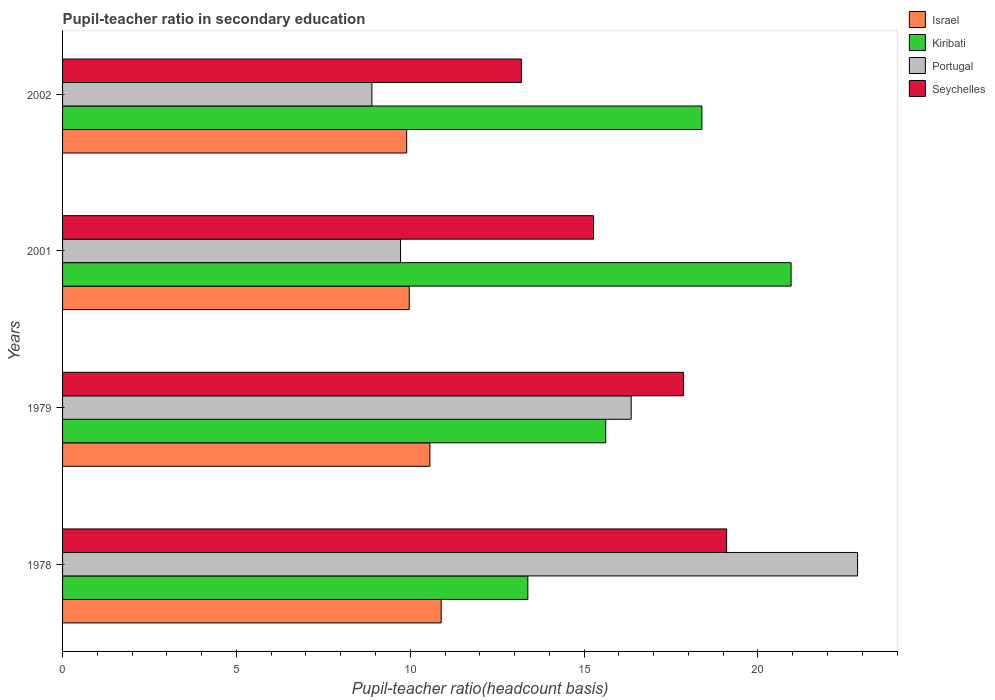How many groups of bars are there?
Make the answer very short. 4. Are the number of bars per tick equal to the number of legend labels?
Your answer should be very brief. Yes. Are the number of bars on each tick of the Y-axis equal?
Make the answer very short. Yes. How many bars are there on the 4th tick from the top?
Offer a terse response. 4. How many bars are there on the 2nd tick from the bottom?
Keep it short and to the point. 4. What is the label of the 4th group of bars from the top?
Your response must be concise. 1978. What is the pupil-teacher ratio in secondary education in Portugal in 2001?
Your response must be concise. 9.72. Across all years, what is the maximum pupil-teacher ratio in secondary education in Seychelles?
Offer a terse response. 19.1. Across all years, what is the minimum pupil-teacher ratio in secondary education in Portugal?
Offer a very short reply. 8.9. In which year was the pupil-teacher ratio in secondary education in Kiribati maximum?
Make the answer very short. 2001. In which year was the pupil-teacher ratio in secondary education in Portugal minimum?
Provide a succinct answer. 2002. What is the total pupil-teacher ratio in secondary education in Israel in the graph?
Give a very brief answer. 41.32. What is the difference between the pupil-teacher ratio in secondary education in Portugal in 1979 and that in 2001?
Your response must be concise. 6.63. What is the difference between the pupil-teacher ratio in secondary education in Portugal in 1978 and the pupil-teacher ratio in secondary education in Seychelles in 2001?
Ensure brevity in your answer.  7.6. What is the average pupil-teacher ratio in secondary education in Seychelles per year?
Provide a succinct answer. 16.36. In the year 2002, what is the difference between the pupil-teacher ratio in secondary education in Portugal and pupil-teacher ratio in secondary education in Israel?
Provide a succinct answer. -1. In how many years, is the pupil-teacher ratio in secondary education in Seychelles greater than 12 ?
Make the answer very short. 4. What is the ratio of the pupil-teacher ratio in secondary education in Israel in 1978 to that in 1979?
Offer a terse response. 1.03. Is the pupil-teacher ratio in secondary education in Kiribati in 1979 less than that in 2001?
Your response must be concise. Yes. Is the difference between the pupil-teacher ratio in secondary education in Portugal in 1978 and 2001 greater than the difference between the pupil-teacher ratio in secondary education in Israel in 1978 and 2001?
Ensure brevity in your answer.  Yes. What is the difference between the highest and the second highest pupil-teacher ratio in secondary education in Seychelles?
Your response must be concise. 1.24. What is the difference between the highest and the lowest pupil-teacher ratio in secondary education in Seychelles?
Provide a succinct answer. 5.9. Is it the case that in every year, the sum of the pupil-teacher ratio in secondary education in Portugal and pupil-teacher ratio in secondary education in Israel is greater than the sum of pupil-teacher ratio in secondary education in Seychelles and pupil-teacher ratio in secondary education in Kiribati?
Provide a short and direct response. No. What does the 2nd bar from the bottom in 2002 represents?
Give a very brief answer. Kiribati. Is it the case that in every year, the sum of the pupil-teacher ratio in secondary education in Portugal and pupil-teacher ratio in secondary education in Israel is greater than the pupil-teacher ratio in secondary education in Kiribati?
Keep it short and to the point. No. How many bars are there?
Your answer should be compact. 16. Are all the bars in the graph horizontal?
Your answer should be compact. Yes. How many years are there in the graph?
Keep it short and to the point. 4. What is the difference between two consecutive major ticks on the X-axis?
Provide a short and direct response. 5. Does the graph contain grids?
Ensure brevity in your answer.  No. How are the legend labels stacked?
Offer a terse response. Vertical. What is the title of the graph?
Provide a succinct answer. Pupil-teacher ratio in secondary education. What is the label or title of the X-axis?
Offer a very short reply. Pupil-teacher ratio(headcount basis). What is the Pupil-teacher ratio(headcount basis) of Israel in 1978?
Your response must be concise. 10.89. What is the Pupil-teacher ratio(headcount basis) in Kiribati in 1978?
Give a very brief answer. 13.38. What is the Pupil-teacher ratio(headcount basis) of Portugal in 1978?
Offer a terse response. 22.87. What is the Pupil-teacher ratio(headcount basis) of Seychelles in 1978?
Your answer should be very brief. 19.1. What is the Pupil-teacher ratio(headcount basis) of Israel in 1979?
Offer a terse response. 10.57. What is the Pupil-teacher ratio(headcount basis) of Kiribati in 1979?
Your answer should be very brief. 15.62. What is the Pupil-teacher ratio(headcount basis) in Portugal in 1979?
Keep it short and to the point. 16.35. What is the Pupil-teacher ratio(headcount basis) in Seychelles in 1979?
Give a very brief answer. 17.86. What is the Pupil-teacher ratio(headcount basis) in Israel in 2001?
Make the answer very short. 9.97. What is the Pupil-teacher ratio(headcount basis) of Kiribati in 2001?
Your answer should be compact. 20.95. What is the Pupil-teacher ratio(headcount basis) of Portugal in 2001?
Keep it short and to the point. 9.72. What is the Pupil-teacher ratio(headcount basis) in Seychelles in 2001?
Provide a short and direct response. 15.27. What is the Pupil-teacher ratio(headcount basis) of Israel in 2002?
Your answer should be compact. 9.9. What is the Pupil-teacher ratio(headcount basis) of Kiribati in 2002?
Keep it short and to the point. 18.39. What is the Pupil-teacher ratio(headcount basis) in Portugal in 2002?
Your answer should be very brief. 8.9. What is the Pupil-teacher ratio(headcount basis) of Seychelles in 2002?
Your answer should be very brief. 13.2. Across all years, what is the maximum Pupil-teacher ratio(headcount basis) in Israel?
Provide a short and direct response. 10.89. Across all years, what is the maximum Pupil-teacher ratio(headcount basis) of Kiribati?
Your response must be concise. 20.95. Across all years, what is the maximum Pupil-teacher ratio(headcount basis) of Portugal?
Your answer should be very brief. 22.87. Across all years, what is the maximum Pupil-teacher ratio(headcount basis) of Seychelles?
Ensure brevity in your answer.  19.1. Across all years, what is the minimum Pupil-teacher ratio(headcount basis) in Israel?
Your answer should be compact. 9.9. Across all years, what is the minimum Pupil-teacher ratio(headcount basis) in Kiribati?
Provide a short and direct response. 13.38. Across all years, what is the minimum Pupil-teacher ratio(headcount basis) of Portugal?
Provide a short and direct response. 8.9. Across all years, what is the minimum Pupil-teacher ratio(headcount basis) of Seychelles?
Provide a succinct answer. 13.2. What is the total Pupil-teacher ratio(headcount basis) in Israel in the graph?
Make the answer very short. 41.32. What is the total Pupil-teacher ratio(headcount basis) of Kiribati in the graph?
Your answer should be very brief. 68.34. What is the total Pupil-teacher ratio(headcount basis) in Portugal in the graph?
Keep it short and to the point. 57.84. What is the total Pupil-teacher ratio(headcount basis) of Seychelles in the graph?
Your response must be concise. 65.42. What is the difference between the Pupil-teacher ratio(headcount basis) of Israel in 1978 and that in 1979?
Offer a terse response. 0.32. What is the difference between the Pupil-teacher ratio(headcount basis) in Kiribati in 1978 and that in 1979?
Provide a succinct answer. -2.24. What is the difference between the Pupil-teacher ratio(headcount basis) of Portugal in 1978 and that in 1979?
Your answer should be very brief. 6.51. What is the difference between the Pupil-teacher ratio(headcount basis) in Seychelles in 1978 and that in 1979?
Make the answer very short. 1.24. What is the difference between the Pupil-teacher ratio(headcount basis) in Israel in 1978 and that in 2001?
Make the answer very short. 0.92. What is the difference between the Pupil-teacher ratio(headcount basis) of Kiribati in 1978 and that in 2001?
Your response must be concise. -7.57. What is the difference between the Pupil-teacher ratio(headcount basis) in Portugal in 1978 and that in 2001?
Offer a very short reply. 13.15. What is the difference between the Pupil-teacher ratio(headcount basis) in Seychelles in 1978 and that in 2001?
Offer a very short reply. 3.83. What is the difference between the Pupil-teacher ratio(headcount basis) of Israel in 1978 and that in 2002?
Provide a succinct answer. 0.99. What is the difference between the Pupil-teacher ratio(headcount basis) in Kiribati in 1978 and that in 2002?
Your answer should be compact. -5.01. What is the difference between the Pupil-teacher ratio(headcount basis) of Portugal in 1978 and that in 2002?
Provide a short and direct response. 13.97. What is the difference between the Pupil-teacher ratio(headcount basis) in Seychelles in 1978 and that in 2002?
Ensure brevity in your answer.  5.9. What is the difference between the Pupil-teacher ratio(headcount basis) in Israel in 1979 and that in 2001?
Make the answer very short. 0.59. What is the difference between the Pupil-teacher ratio(headcount basis) of Kiribati in 1979 and that in 2001?
Your answer should be very brief. -5.33. What is the difference between the Pupil-teacher ratio(headcount basis) of Portugal in 1979 and that in 2001?
Offer a terse response. 6.63. What is the difference between the Pupil-teacher ratio(headcount basis) in Seychelles in 1979 and that in 2001?
Ensure brevity in your answer.  2.59. What is the difference between the Pupil-teacher ratio(headcount basis) of Israel in 1979 and that in 2002?
Offer a very short reply. 0.67. What is the difference between the Pupil-teacher ratio(headcount basis) in Kiribati in 1979 and that in 2002?
Provide a succinct answer. -2.77. What is the difference between the Pupil-teacher ratio(headcount basis) of Portugal in 1979 and that in 2002?
Your answer should be compact. 7.46. What is the difference between the Pupil-teacher ratio(headcount basis) of Seychelles in 1979 and that in 2002?
Offer a terse response. 4.66. What is the difference between the Pupil-teacher ratio(headcount basis) in Israel in 2001 and that in 2002?
Keep it short and to the point. 0.07. What is the difference between the Pupil-teacher ratio(headcount basis) of Kiribati in 2001 and that in 2002?
Provide a short and direct response. 2.57. What is the difference between the Pupil-teacher ratio(headcount basis) in Portugal in 2001 and that in 2002?
Your response must be concise. 0.82. What is the difference between the Pupil-teacher ratio(headcount basis) in Seychelles in 2001 and that in 2002?
Provide a short and direct response. 2.07. What is the difference between the Pupil-teacher ratio(headcount basis) in Israel in 1978 and the Pupil-teacher ratio(headcount basis) in Kiribati in 1979?
Keep it short and to the point. -4.73. What is the difference between the Pupil-teacher ratio(headcount basis) in Israel in 1978 and the Pupil-teacher ratio(headcount basis) in Portugal in 1979?
Make the answer very short. -5.46. What is the difference between the Pupil-teacher ratio(headcount basis) in Israel in 1978 and the Pupil-teacher ratio(headcount basis) in Seychelles in 1979?
Your answer should be compact. -6.97. What is the difference between the Pupil-teacher ratio(headcount basis) in Kiribati in 1978 and the Pupil-teacher ratio(headcount basis) in Portugal in 1979?
Keep it short and to the point. -2.97. What is the difference between the Pupil-teacher ratio(headcount basis) in Kiribati in 1978 and the Pupil-teacher ratio(headcount basis) in Seychelles in 1979?
Your response must be concise. -4.48. What is the difference between the Pupil-teacher ratio(headcount basis) of Portugal in 1978 and the Pupil-teacher ratio(headcount basis) of Seychelles in 1979?
Offer a terse response. 5.01. What is the difference between the Pupil-teacher ratio(headcount basis) of Israel in 1978 and the Pupil-teacher ratio(headcount basis) of Kiribati in 2001?
Give a very brief answer. -10.06. What is the difference between the Pupil-teacher ratio(headcount basis) of Israel in 1978 and the Pupil-teacher ratio(headcount basis) of Portugal in 2001?
Provide a short and direct response. 1.17. What is the difference between the Pupil-teacher ratio(headcount basis) of Israel in 1978 and the Pupil-teacher ratio(headcount basis) of Seychelles in 2001?
Ensure brevity in your answer.  -4.38. What is the difference between the Pupil-teacher ratio(headcount basis) of Kiribati in 1978 and the Pupil-teacher ratio(headcount basis) of Portugal in 2001?
Your answer should be compact. 3.66. What is the difference between the Pupil-teacher ratio(headcount basis) of Kiribati in 1978 and the Pupil-teacher ratio(headcount basis) of Seychelles in 2001?
Provide a succinct answer. -1.89. What is the difference between the Pupil-teacher ratio(headcount basis) in Portugal in 1978 and the Pupil-teacher ratio(headcount basis) in Seychelles in 2001?
Offer a very short reply. 7.6. What is the difference between the Pupil-teacher ratio(headcount basis) in Israel in 1978 and the Pupil-teacher ratio(headcount basis) in Kiribati in 2002?
Keep it short and to the point. -7.5. What is the difference between the Pupil-teacher ratio(headcount basis) in Israel in 1978 and the Pupil-teacher ratio(headcount basis) in Portugal in 2002?
Make the answer very short. 1.99. What is the difference between the Pupil-teacher ratio(headcount basis) in Israel in 1978 and the Pupil-teacher ratio(headcount basis) in Seychelles in 2002?
Keep it short and to the point. -2.31. What is the difference between the Pupil-teacher ratio(headcount basis) in Kiribati in 1978 and the Pupil-teacher ratio(headcount basis) in Portugal in 2002?
Your response must be concise. 4.48. What is the difference between the Pupil-teacher ratio(headcount basis) in Kiribati in 1978 and the Pupil-teacher ratio(headcount basis) in Seychelles in 2002?
Make the answer very short. 0.18. What is the difference between the Pupil-teacher ratio(headcount basis) in Portugal in 1978 and the Pupil-teacher ratio(headcount basis) in Seychelles in 2002?
Give a very brief answer. 9.67. What is the difference between the Pupil-teacher ratio(headcount basis) of Israel in 1979 and the Pupil-teacher ratio(headcount basis) of Kiribati in 2001?
Make the answer very short. -10.39. What is the difference between the Pupil-teacher ratio(headcount basis) in Israel in 1979 and the Pupil-teacher ratio(headcount basis) in Portugal in 2001?
Your answer should be compact. 0.84. What is the difference between the Pupil-teacher ratio(headcount basis) in Israel in 1979 and the Pupil-teacher ratio(headcount basis) in Seychelles in 2001?
Provide a short and direct response. -4.71. What is the difference between the Pupil-teacher ratio(headcount basis) of Kiribati in 1979 and the Pupil-teacher ratio(headcount basis) of Portugal in 2001?
Your response must be concise. 5.9. What is the difference between the Pupil-teacher ratio(headcount basis) in Kiribati in 1979 and the Pupil-teacher ratio(headcount basis) in Seychelles in 2001?
Offer a terse response. 0.35. What is the difference between the Pupil-teacher ratio(headcount basis) in Portugal in 1979 and the Pupil-teacher ratio(headcount basis) in Seychelles in 2001?
Ensure brevity in your answer.  1.08. What is the difference between the Pupil-teacher ratio(headcount basis) in Israel in 1979 and the Pupil-teacher ratio(headcount basis) in Kiribati in 2002?
Provide a short and direct response. -7.82. What is the difference between the Pupil-teacher ratio(headcount basis) of Israel in 1979 and the Pupil-teacher ratio(headcount basis) of Portugal in 2002?
Your answer should be compact. 1.67. What is the difference between the Pupil-teacher ratio(headcount basis) in Israel in 1979 and the Pupil-teacher ratio(headcount basis) in Seychelles in 2002?
Your answer should be very brief. -2.63. What is the difference between the Pupil-teacher ratio(headcount basis) in Kiribati in 1979 and the Pupil-teacher ratio(headcount basis) in Portugal in 2002?
Provide a succinct answer. 6.72. What is the difference between the Pupil-teacher ratio(headcount basis) of Kiribati in 1979 and the Pupil-teacher ratio(headcount basis) of Seychelles in 2002?
Give a very brief answer. 2.42. What is the difference between the Pupil-teacher ratio(headcount basis) in Portugal in 1979 and the Pupil-teacher ratio(headcount basis) in Seychelles in 2002?
Offer a very short reply. 3.16. What is the difference between the Pupil-teacher ratio(headcount basis) of Israel in 2001 and the Pupil-teacher ratio(headcount basis) of Kiribati in 2002?
Provide a succinct answer. -8.42. What is the difference between the Pupil-teacher ratio(headcount basis) in Israel in 2001 and the Pupil-teacher ratio(headcount basis) in Portugal in 2002?
Give a very brief answer. 1.07. What is the difference between the Pupil-teacher ratio(headcount basis) of Israel in 2001 and the Pupil-teacher ratio(headcount basis) of Seychelles in 2002?
Your answer should be compact. -3.23. What is the difference between the Pupil-teacher ratio(headcount basis) of Kiribati in 2001 and the Pupil-teacher ratio(headcount basis) of Portugal in 2002?
Your answer should be very brief. 12.06. What is the difference between the Pupil-teacher ratio(headcount basis) in Kiribati in 2001 and the Pupil-teacher ratio(headcount basis) in Seychelles in 2002?
Provide a succinct answer. 7.76. What is the difference between the Pupil-teacher ratio(headcount basis) in Portugal in 2001 and the Pupil-teacher ratio(headcount basis) in Seychelles in 2002?
Offer a terse response. -3.48. What is the average Pupil-teacher ratio(headcount basis) of Israel per year?
Ensure brevity in your answer.  10.33. What is the average Pupil-teacher ratio(headcount basis) in Kiribati per year?
Ensure brevity in your answer.  17.09. What is the average Pupil-teacher ratio(headcount basis) of Portugal per year?
Keep it short and to the point. 14.46. What is the average Pupil-teacher ratio(headcount basis) in Seychelles per year?
Offer a terse response. 16.36. In the year 1978, what is the difference between the Pupil-teacher ratio(headcount basis) of Israel and Pupil-teacher ratio(headcount basis) of Kiribati?
Keep it short and to the point. -2.49. In the year 1978, what is the difference between the Pupil-teacher ratio(headcount basis) of Israel and Pupil-teacher ratio(headcount basis) of Portugal?
Your answer should be very brief. -11.98. In the year 1978, what is the difference between the Pupil-teacher ratio(headcount basis) of Israel and Pupil-teacher ratio(headcount basis) of Seychelles?
Provide a succinct answer. -8.21. In the year 1978, what is the difference between the Pupil-teacher ratio(headcount basis) of Kiribati and Pupil-teacher ratio(headcount basis) of Portugal?
Offer a very short reply. -9.48. In the year 1978, what is the difference between the Pupil-teacher ratio(headcount basis) of Kiribati and Pupil-teacher ratio(headcount basis) of Seychelles?
Offer a very short reply. -5.72. In the year 1978, what is the difference between the Pupil-teacher ratio(headcount basis) in Portugal and Pupil-teacher ratio(headcount basis) in Seychelles?
Make the answer very short. 3.77. In the year 1979, what is the difference between the Pupil-teacher ratio(headcount basis) in Israel and Pupil-teacher ratio(headcount basis) in Kiribati?
Offer a very short reply. -5.06. In the year 1979, what is the difference between the Pupil-teacher ratio(headcount basis) of Israel and Pupil-teacher ratio(headcount basis) of Portugal?
Offer a terse response. -5.79. In the year 1979, what is the difference between the Pupil-teacher ratio(headcount basis) in Israel and Pupil-teacher ratio(headcount basis) in Seychelles?
Ensure brevity in your answer.  -7.29. In the year 1979, what is the difference between the Pupil-teacher ratio(headcount basis) of Kiribati and Pupil-teacher ratio(headcount basis) of Portugal?
Provide a short and direct response. -0.73. In the year 1979, what is the difference between the Pupil-teacher ratio(headcount basis) in Kiribati and Pupil-teacher ratio(headcount basis) in Seychelles?
Offer a very short reply. -2.24. In the year 1979, what is the difference between the Pupil-teacher ratio(headcount basis) in Portugal and Pupil-teacher ratio(headcount basis) in Seychelles?
Provide a short and direct response. -1.5. In the year 2001, what is the difference between the Pupil-teacher ratio(headcount basis) in Israel and Pupil-teacher ratio(headcount basis) in Kiribati?
Provide a short and direct response. -10.98. In the year 2001, what is the difference between the Pupil-teacher ratio(headcount basis) of Israel and Pupil-teacher ratio(headcount basis) of Portugal?
Give a very brief answer. 0.25. In the year 2001, what is the difference between the Pupil-teacher ratio(headcount basis) in Israel and Pupil-teacher ratio(headcount basis) in Seychelles?
Ensure brevity in your answer.  -5.3. In the year 2001, what is the difference between the Pupil-teacher ratio(headcount basis) of Kiribati and Pupil-teacher ratio(headcount basis) of Portugal?
Provide a succinct answer. 11.23. In the year 2001, what is the difference between the Pupil-teacher ratio(headcount basis) of Kiribati and Pupil-teacher ratio(headcount basis) of Seychelles?
Keep it short and to the point. 5.68. In the year 2001, what is the difference between the Pupil-teacher ratio(headcount basis) of Portugal and Pupil-teacher ratio(headcount basis) of Seychelles?
Give a very brief answer. -5.55. In the year 2002, what is the difference between the Pupil-teacher ratio(headcount basis) of Israel and Pupil-teacher ratio(headcount basis) of Kiribati?
Your answer should be compact. -8.49. In the year 2002, what is the difference between the Pupil-teacher ratio(headcount basis) in Israel and Pupil-teacher ratio(headcount basis) in Seychelles?
Your answer should be compact. -3.3. In the year 2002, what is the difference between the Pupil-teacher ratio(headcount basis) in Kiribati and Pupil-teacher ratio(headcount basis) in Portugal?
Your answer should be very brief. 9.49. In the year 2002, what is the difference between the Pupil-teacher ratio(headcount basis) of Kiribati and Pupil-teacher ratio(headcount basis) of Seychelles?
Your answer should be compact. 5.19. In the year 2002, what is the difference between the Pupil-teacher ratio(headcount basis) of Portugal and Pupil-teacher ratio(headcount basis) of Seychelles?
Provide a short and direct response. -4.3. What is the ratio of the Pupil-teacher ratio(headcount basis) of Israel in 1978 to that in 1979?
Your answer should be very brief. 1.03. What is the ratio of the Pupil-teacher ratio(headcount basis) in Kiribati in 1978 to that in 1979?
Provide a short and direct response. 0.86. What is the ratio of the Pupil-teacher ratio(headcount basis) in Portugal in 1978 to that in 1979?
Offer a very short reply. 1.4. What is the ratio of the Pupil-teacher ratio(headcount basis) of Seychelles in 1978 to that in 1979?
Your response must be concise. 1.07. What is the ratio of the Pupil-teacher ratio(headcount basis) of Israel in 1978 to that in 2001?
Provide a succinct answer. 1.09. What is the ratio of the Pupil-teacher ratio(headcount basis) in Kiribati in 1978 to that in 2001?
Provide a succinct answer. 0.64. What is the ratio of the Pupil-teacher ratio(headcount basis) in Portugal in 1978 to that in 2001?
Keep it short and to the point. 2.35. What is the ratio of the Pupil-teacher ratio(headcount basis) of Seychelles in 1978 to that in 2001?
Ensure brevity in your answer.  1.25. What is the ratio of the Pupil-teacher ratio(headcount basis) in Israel in 1978 to that in 2002?
Give a very brief answer. 1.1. What is the ratio of the Pupil-teacher ratio(headcount basis) in Kiribati in 1978 to that in 2002?
Keep it short and to the point. 0.73. What is the ratio of the Pupil-teacher ratio(headcount basis) in Portugal in 1978 to that in 2002?
Provide a succinct answer. 2.57. What is the ratio of the Pupil-teacher ratio(headcount basis) of Seychelles in 1978 to that in 2002?
Offer a terse response. 1.45. What is the ratio of the Pupil-teacher ratio(headcount basis) in Israel in 1979 to that in 2001?
Offer a very short reply. 1.06. What is the ratio of the Pupil-teacher ratio(headcount basis) of Kiribati in 1979 to that in 2001?
Offer a very short reply. 0.75. What is the ratio of the Pupil-teacher ratio(headcount basis) in Portugal in 1979 to that in 2001?
Offer a very short reply. 1.68. What is the ratio of the Pupil-teacher ratio(headcount basis) in Seychelles in 1979 to that in 2001?
Offer a very short reply. 1.17. What is the ratio of the Pupil-teacher ratio(headcount basis) of Israel in 1979 to that in 2002?
Keep it short and to the point. 1.07. What is the ratio of the Pupil-teacher ratio(headcount basis) in Kiribati in 1979 to that in 2002?
Your answer should be very brief. 0.85. What is the ratio of the Pupil-teacher ratio(headcount basis) in Portugal in 1979 to that in 2002?
Ensure brevity in your answer.  1.84. What is the ratio of the Pupil-teacher ratio(headcount basis) of Seychelles in 1979 to that in 2002?
Offer a very short reply. 1.35. What is the ratio of the Pupil-teacher ratio(headcount basis) of Israel in 2001 to that in 2002?
Offer a very short reply. 1.01. What is the ratio of the Pupil-teacher ratio(headcount basis) in Kiribati in 2001 to that in 2002?
Give a very brief answer. 1.14. What is the ratio of the Pupil-teacher ratio(headcount basis) of Portugal in 2001 to that in 2002?
Make the answer very short. 1.09. What is the ratio of the Pupil-teacher ratio(headcount basis) of Seychelles in 2001 to that in 2002?
Ensure brevity in your answer.  1.16. What is the difference between the highest and the second highest Pupil-teacher ratio(headcount basis) of Israel?
Provide a succinct answer. 0.32. What is the difference between the highest and the second highest Pupil-teacher ratio(headcount basis) in Kiribati?
Ensure brevity in your answer.  2.57. What is the difference between the highest and the second highest Pupil-teacher ratio(headcount basis) in Portugal?
Give a very brief answer. 6.51. What is the difference between the highest and the second highest Pupil-teacher ratio(headcount basis) of Seychelles?
Keep it short and to the point. 1.24. What is the difference between the highest and the lowest Pupil-teacher ratio(headcount basis) of Israel?
Offer a terse response. 0.99. What is the difference between the highest and the lowest Pupil-teacher ratio(headcount basis) of Kiribati?
Provide a succinct answer. 7.57. What is the difference between the highest and the lowest Pupil-teacher ratio(headcount basis) in Portugal?
Make the answer very short. 13.97. What is the difference between the highest and the lowest Pupil-teacher ratio(headcount basis) of Seychelles?
Provide a succinct answer. 5.9. 